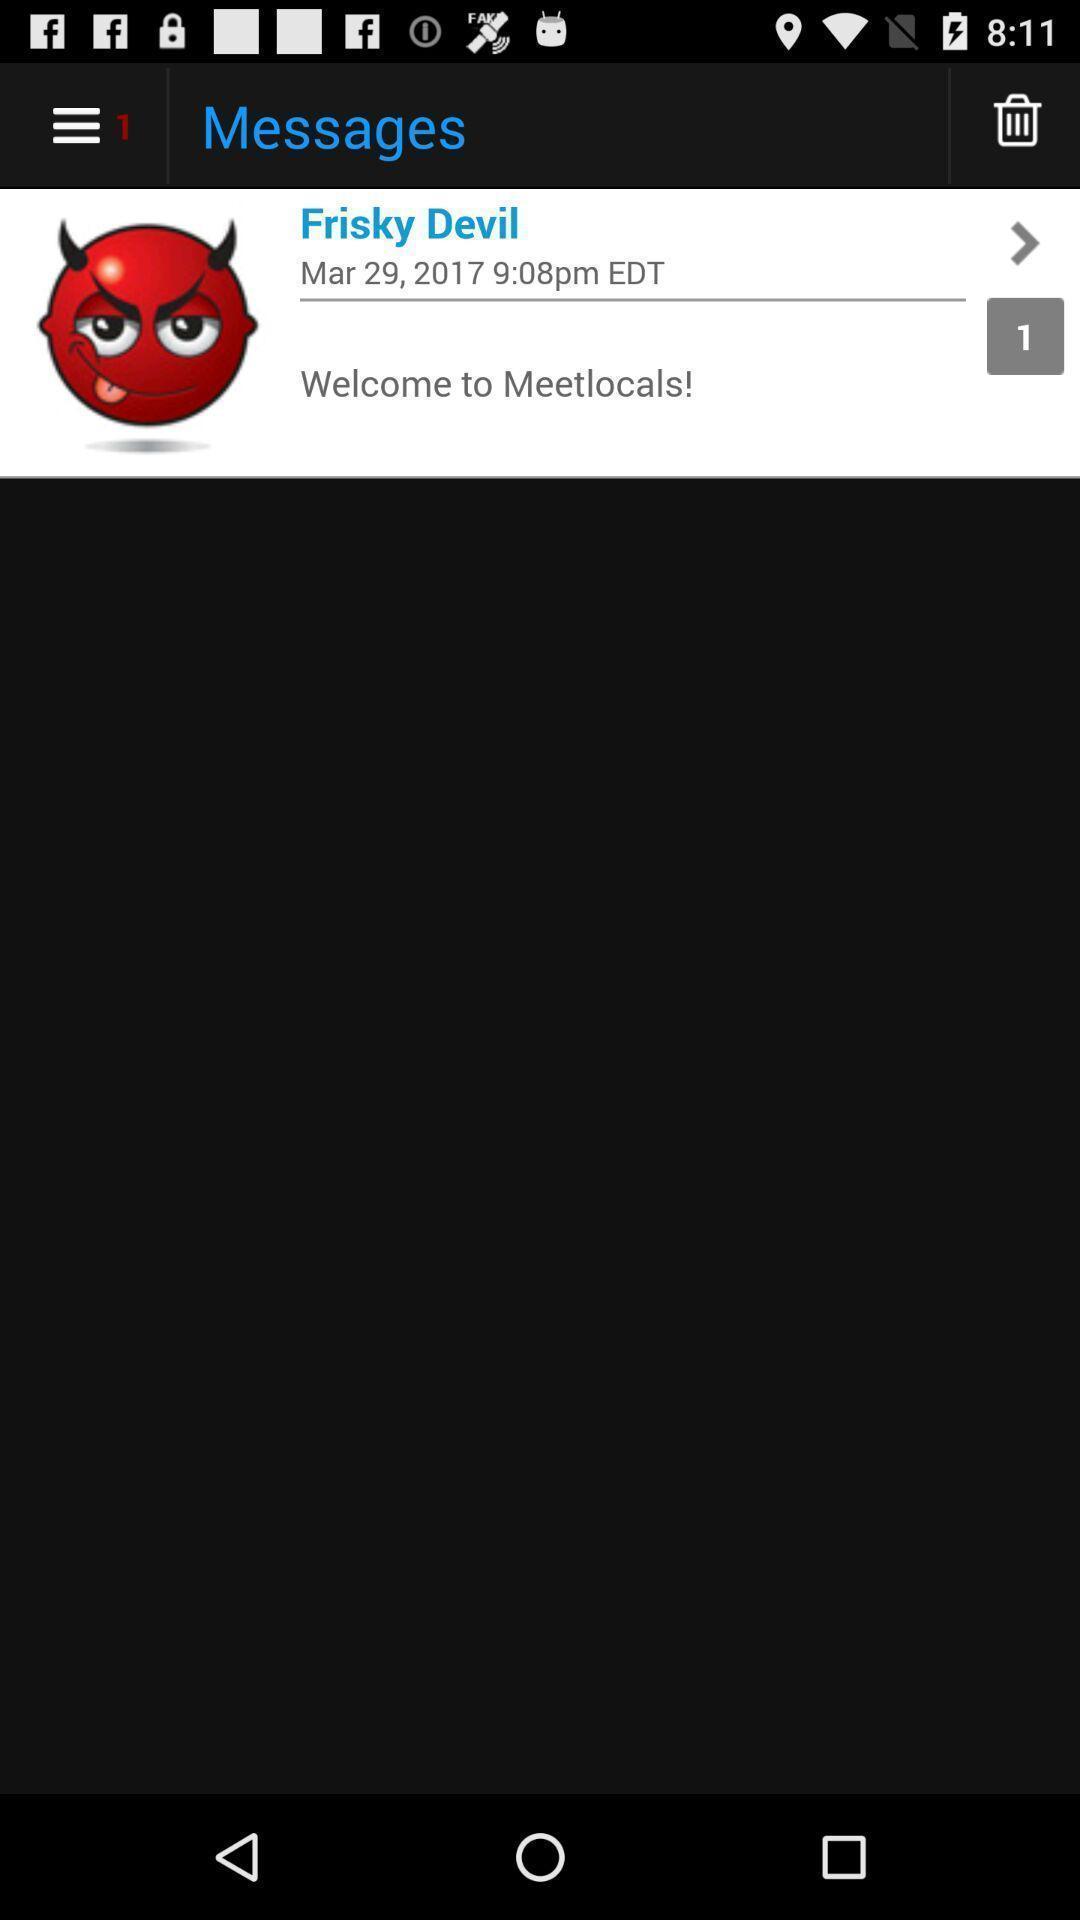Tell me about the visual elements in this screen capture. Welcome page of an social app. 